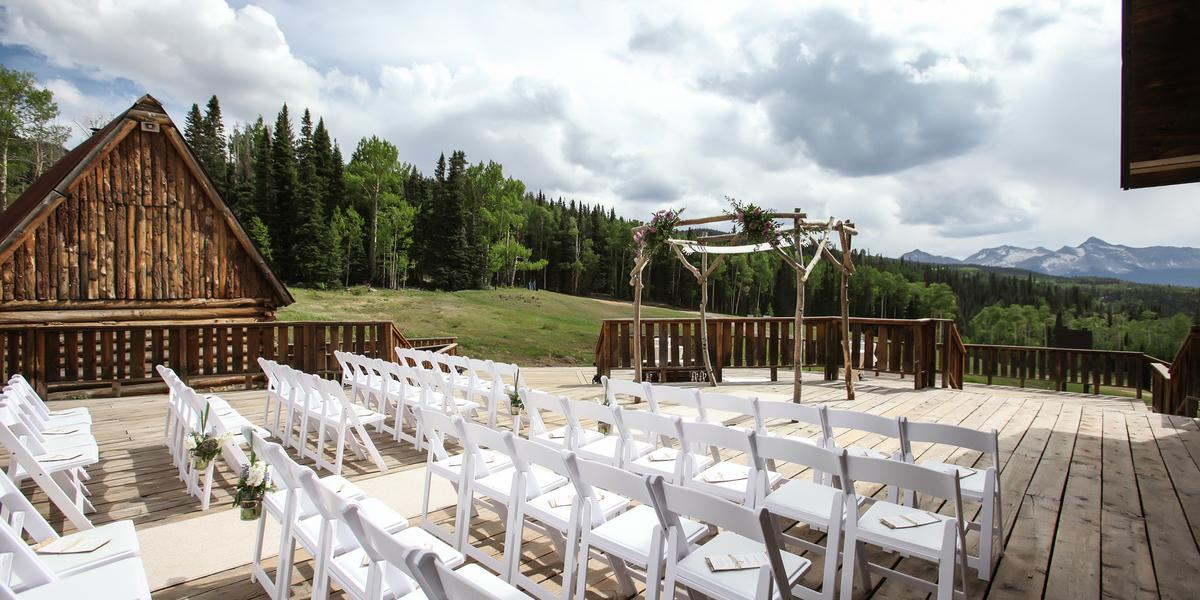What are the environmental considerations to keep in mind for an event at this natural site? Hosting an event at such a picturesque natural site comes with responsibilities to minimize ecological impact. Measures should include using biodegradable or reusable decor items, ensuring all waste is collected and properly disposed of, and possibly working with eco-friendly vendors. Additionally, informing guests about the sensitivity of the surrounding ecosystem and encouraging respectful behavior, such as staying on defined paths to avoid trampling native vegetation, is crucial. 